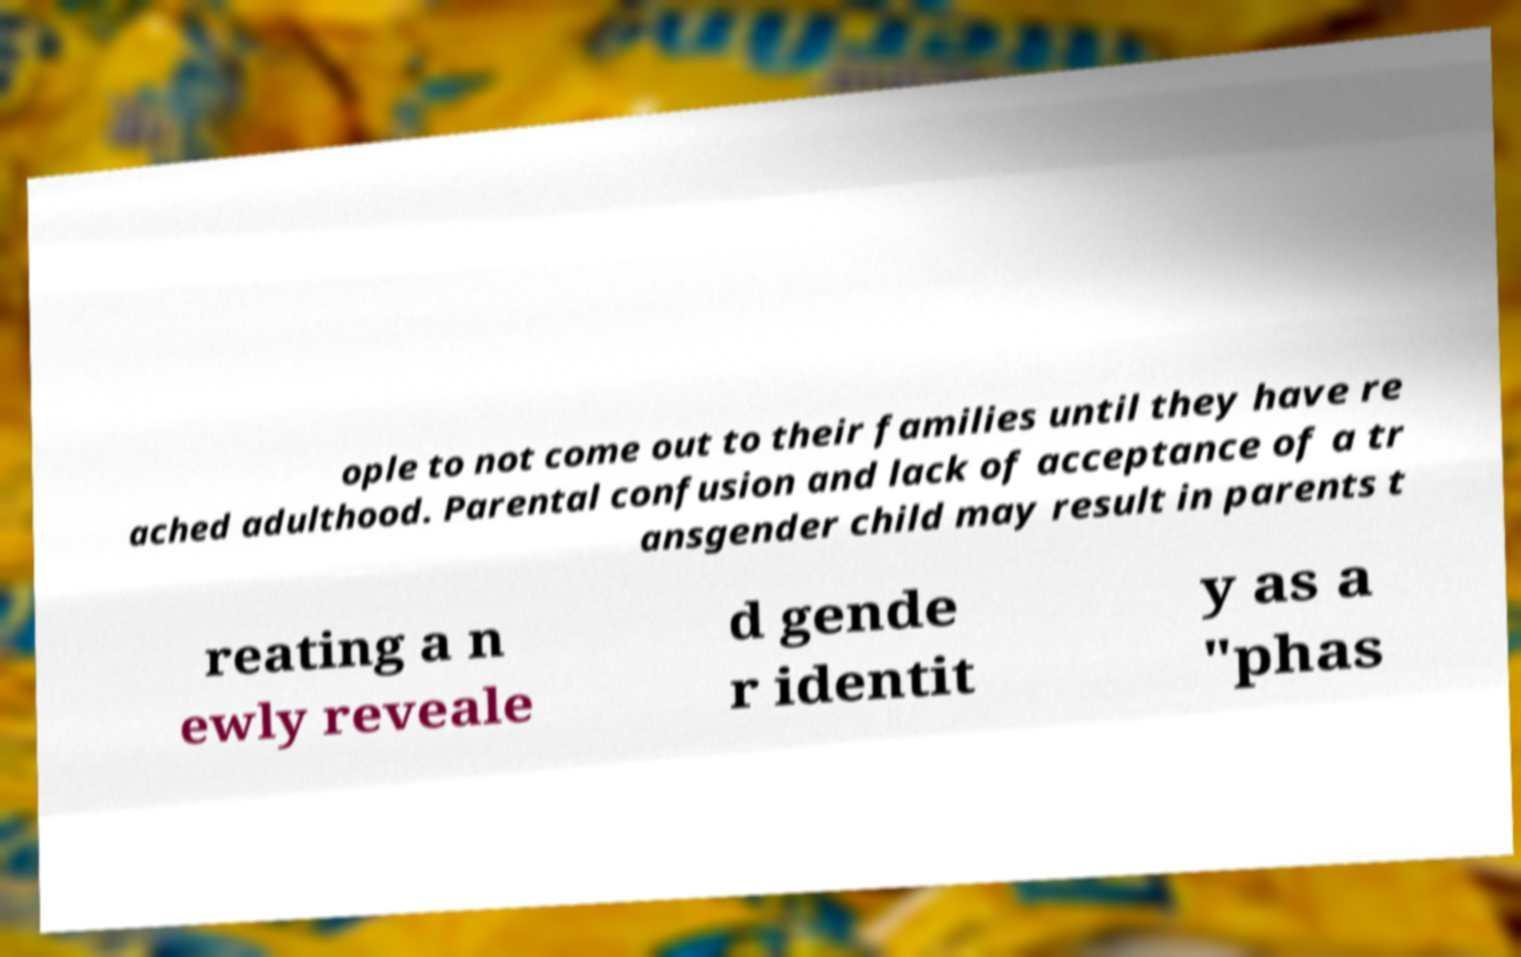What messages or text are displayed in this image? I need them in a readable, typed format. ople to not come out to their families until they have re ached adulthood. Parental confusion and lack of acceptance of a tr ansgender child may result in parents t reating a n ewly reveale d gende r identit y as a "phas 